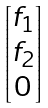Convert formula to latex. <formula><loc_0><loc_0><loc_500><loc_500>\begin{bmatrix} f _ { 1 } \\ f _ { 2 } \\ 0 \end{bmatrix}</formula> 